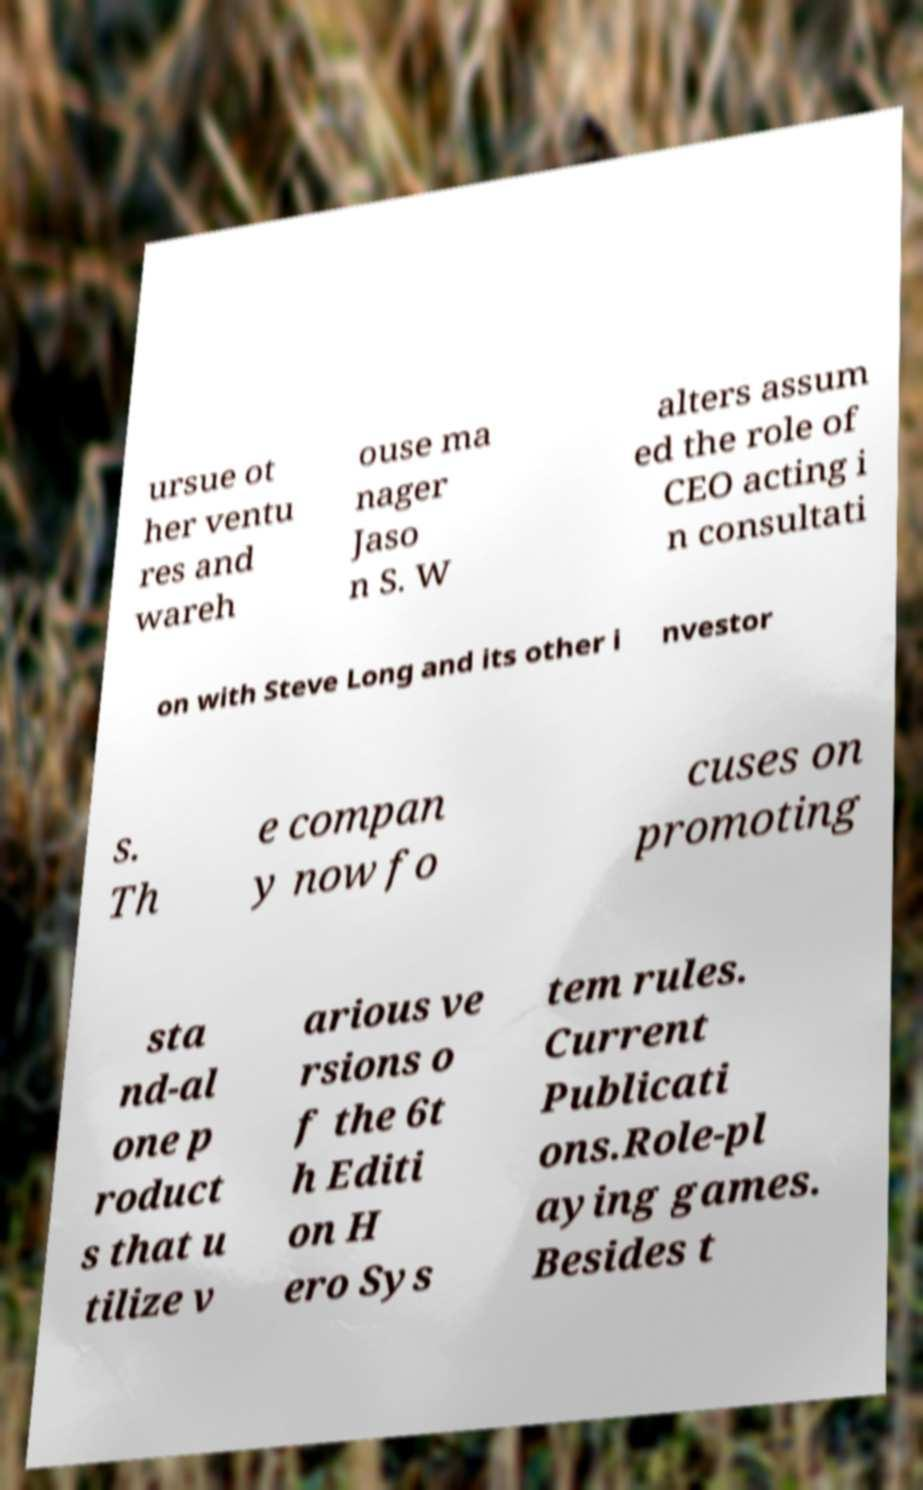Can you accurately transcribe the text from the provided image for me? ursue ot her ventu res and wareh ouse ma nager Jaso n S. W alters assum ed the role of CEO acting i n consultati on with Steve Long and its other i nvestor s. Th e compan y now fo cuses on promoting sta nd-al one p roduct s that u tilize v arious ve rsions o f the 6t h Editi on H ero Sys tem rules. Current Publicati ons.Role-pl aying games. Besides t 